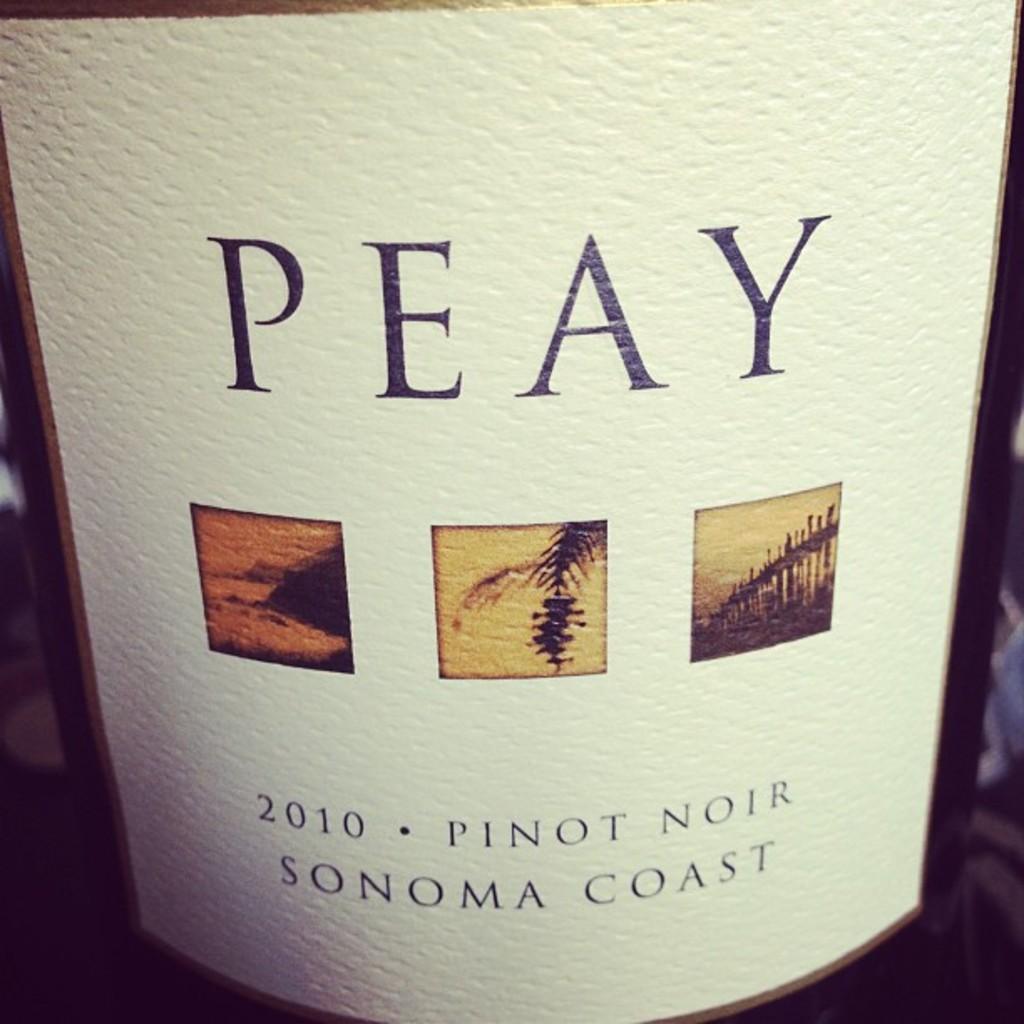What year was this wine made?
Make the answer very short. 2010. 